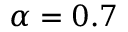Convert formula to latex. <formula><loc_0><loc_0><loc_500><loc_500>\alpha = 0 . 7</formula> 